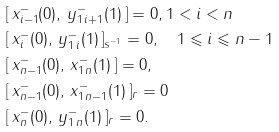<formula> <loc_0><loc_0><loc_500><loc_500>& [ \, x _ { i - 1 } ^ { - } ( 0 ) , \, y _ { 1 \, i + 1 } ^ { - } ( 1 ) \, ] = 0 , 1 < i < n \\ & [ \, x _ { i } ^ { - } ( 0 ) , \, y _ { 1 \, i } ^ { - } ( 1 ) \, ] _ { s ^ { - 1 } } = 0 , \quad 1 \leqslant i \leqslant n - 1 \\ & [ \, x _ { n - 1 } ^ { - } ( 0 ) , \, x _ { 1 \, n } ^ { - } ( 1 ) \, ] = 0 , \\ & [ \, x _ { n - 1 } ^ { - } ( 0 ) , \, x _ { 1 \, n - 1 } ^ { - } ( 1 ) \, ] _ { r } = 0 \\ & [ \, x _ { n } ^ { - } ( 0 ) , \, y _ { 1 \, n } ^ { - } ( 1 ) \, ] _ { r } = 0 .</formula> 